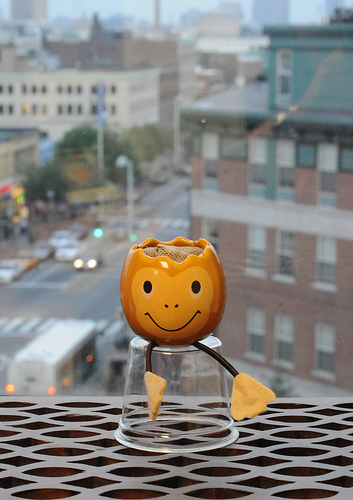<image>
Is the figurine on the grate? Yes. Looking at the image, I can see the figurine is positioned on top of the grate, with the grate providing support. 